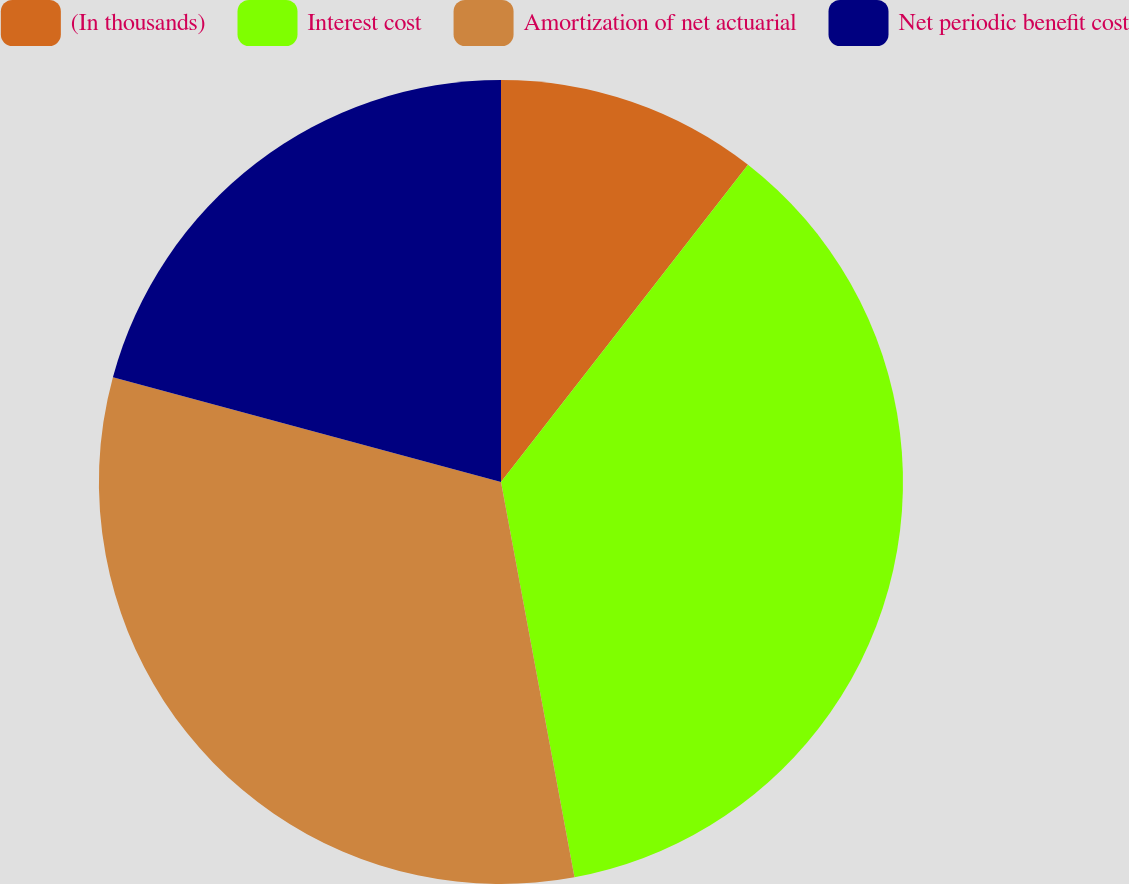<chart> <loc_0><loc_0><loc_500><loc_500><pie_chart><fcel>(In thousands)<fcel>Interest cost<fcel>Amortization of net actuarial<fcel>Net periodic benefit cost<nl><fcel>10.53%<fcel>36.54%<fcel>32.12%<fcel>20.8%<nl></chart> 